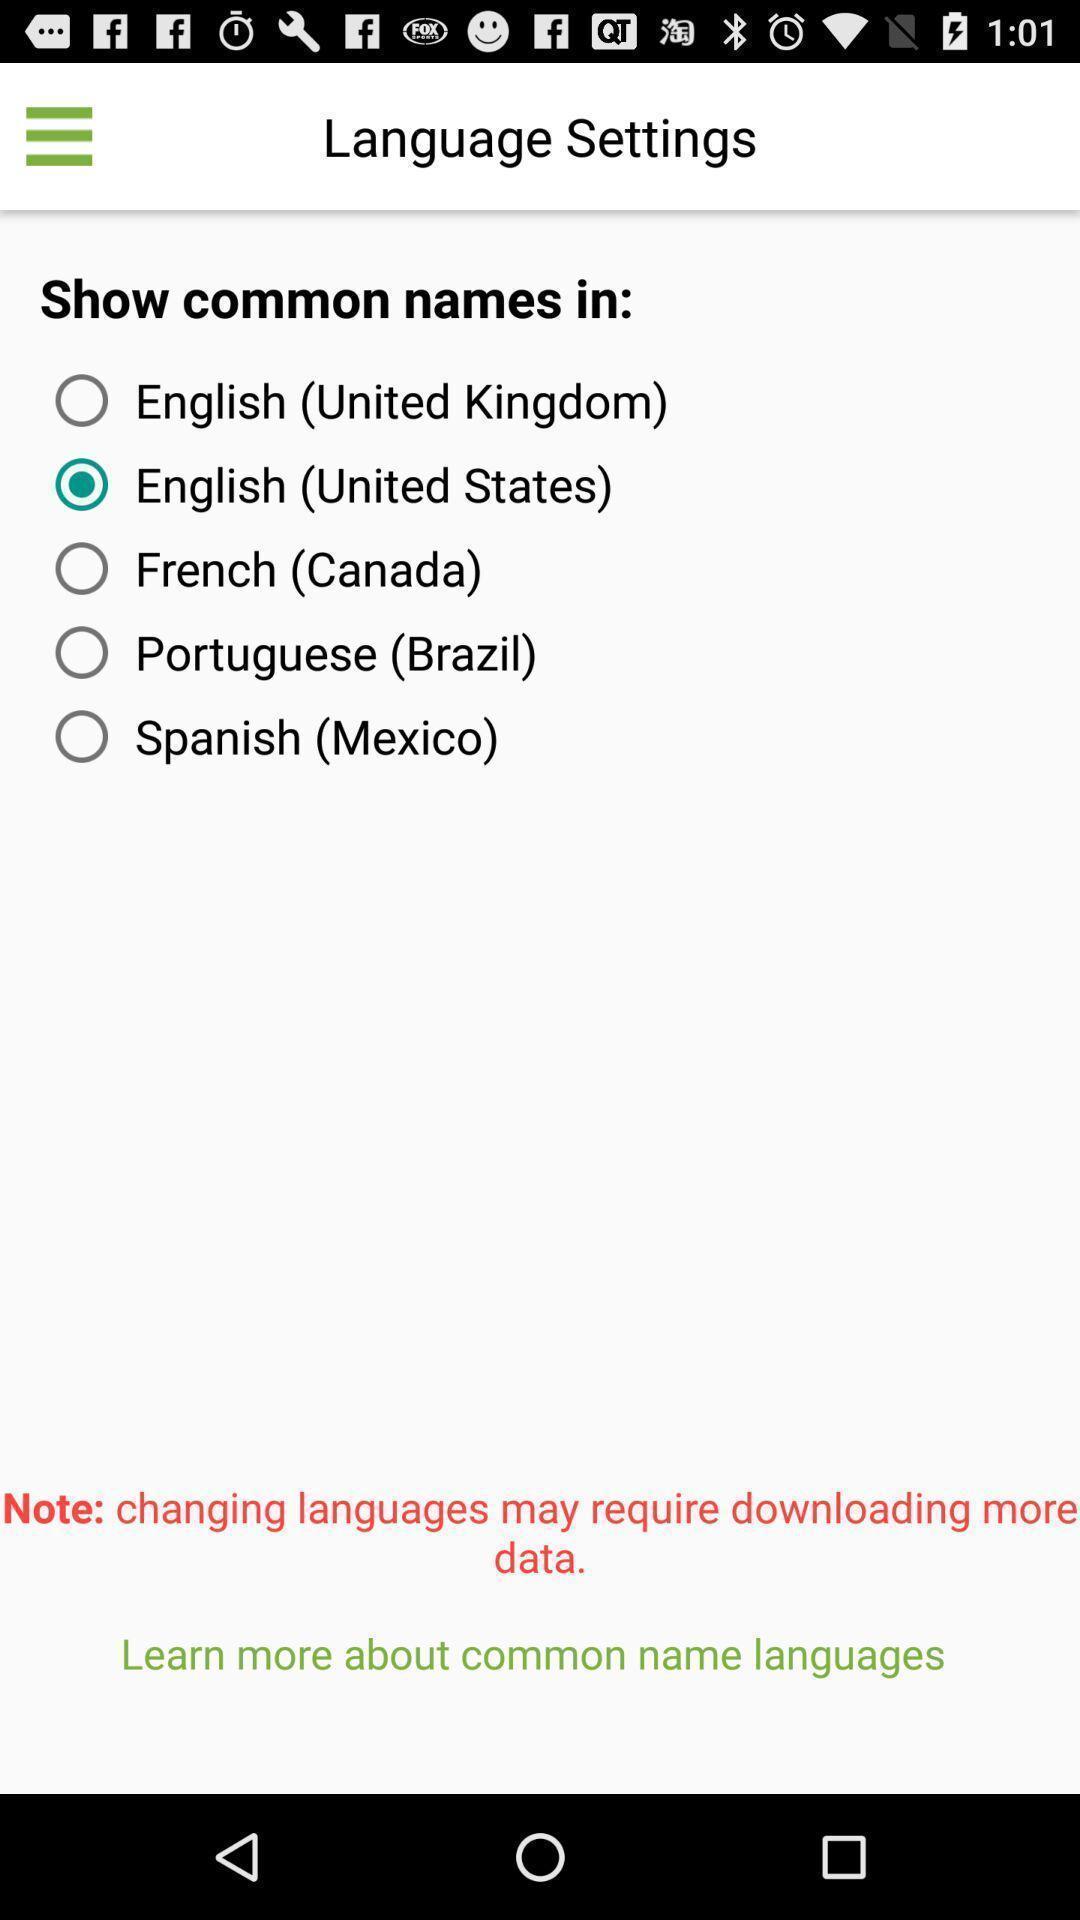Give me a narrative description of this picture. Page shows to select the language. 